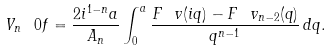Convert formula to latex. <formula><loc_0><loc_0><loc_500><loc_500>V _ { n } \ 0 f = \frac { 2 i ^ { 1 - n } a } { A _ { n } } \int _ { 0 } ^ { a } \frac { F \ v ( i q ) - F \ v _ { n - 2 } ( q ) } { q ^ { n - 1 } } \, d q .</formula> 